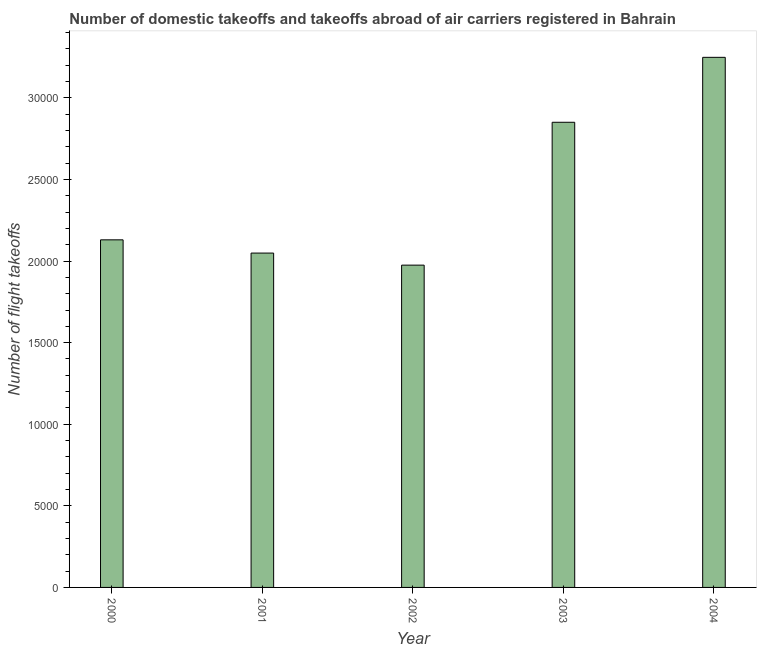What is the title of the graph?
Your answer should be very brief. Number of domestic takeoffs and takeoffs abroad of air carriers registered in Bahrain. What is the label or title of the Y-axis?
Provide a succinct answer. Number of flight takeoffs. What is the number of flight takeoffs in 2002?
Offer a very short reply. 1.98e+04. Across all years, what is the maximum number of flight takeoffs?
Keep it short and to the point. 3.25e+04. Across all years, what is the minimum number of flight takeoffs?
Your answer should be compact. 1.98e+04. What is the sum of the number of flight takeoffs?
Your answer should be very brief. 1.23e+05. What is the difference between the number of flight takeoffs in 2002 and 2003?
Offer a terse response. -8756. What is the average number of flight takeoffs per year?
Provide a succinct answer. 2.45e+04. What is the median number of flight takeoffs?
Your answer should be compact. 2.13e+04. In how many years, is the number of flight takeoffs greater than 27000 ?
Make the answer very short. 2. Do a majority of the years between 2000 and 2004 (inclusive) have number of flight takeoffs greater than 28000 ?
Keep it short and to the point. No. What is the ratio of the number of flight takeoffs in 2002 to that in 2004?
Offer a terse response. 0.61. What is the difference between the highest and the second highest number of flight takeoffs?
Provide a short and direct response. 3980. What is the difference between the highest and the lowest number of flight takeoffs?
Your answer should be compact. 1.27e+04. How many bars are there?
Provide a short and direct response. 5. How many years are there in the graph?
Keep it short and to the point. 5. What is the difference between two consecutive major ticks on the Y-axis?
Provide a short and direct response. 5000. What is the Number of flight takeoffs of 2000?
Offer a very short reply. 2.13e+04. What is the Number of flight takeoffs of 2001?
Provide a succinct answer. 2.05e+04. What is the Number of flight takeoffs in 2002?
Keep it short and to the point. 1.98e+04. What is the Number of flight takeoffs of 2003?
Provide a short and direct response. 2.85e+04. What is the Number of flight takeoffs in 2004?
Your answer should be compact. 3.25e+04. What is the difference between the Number of flight takeoffs in 2000 and 2001?
Your answer should be very brief. 811. What is the difference between the Number of flight takeoffs in 2000 and 2002?
Make the answer very short. 1551. What is the difference between the Number of flight takeoffs in 2000 and 2003?
Ensure brevity in your answer.  -7205. What is the difference between the Number of flight takeoffs in 2000 and 2004?
Ensure brevity in your answer.  -1.12e+04. What is the difference between the Number of flight takeoffs in 2001 and 2002?
Ensure brevity in your answer.  740. What is the difference between the Number of flight takeoffs in 2001 and 2003?
Offer a terse response. -8016. What is the difference between the Number of flight takeoffs in 2001 and 2004?
Your answer should be compact. -1.20e+04. What is the difference between the Number of flight takeoffs in 2002 and 2003?
Provide a short and direct response. -8756. What is the difference between the Number of flight takeoffs in 2002 and 2004?
Keep it short and to the point. -1.27e+04. What is the difference between the Number of flight takeoffs in 2003 and 2004?
Offer a terse response. -3980. What is the ratio of the Number of flight takeoffs in 2000 to that in 2002?
Provide a short and direct response. 1.08. What is the ratio of the Number of flight takeoffs in 2000 to that in 2003?
Your answer should be compact. 0.75. What is the ratio of the Number of flight takeoffs in 2000 to that in 2004?
Offer a very short reply. 0.66. What is the ratio of the Number of flight takeoffs in 2001 to that in 2002?
Provide a short and direct response. 1.04. What is the ratio of the Number of flight takeoffs in 2001 to that in 2003?
Offer a very short reply. 0.72. What is the ratio of the Number of flight takeoffs in 2001 to that in 2004?
Your answer should be very brief. 0.63. What is the ratio of the Number of flight takeoffs in 2002 to that in 2003?
Ensure brevity in your answer.  0.69. What is the ratio of the Number of flight takeoffs in 2002 to that in 2004?
Provide a succinct answer. 0.61. What is the ratio of the Number of flight takeoffs in 2003 to that in 2004?
Your answer should be compact. 0.88. 